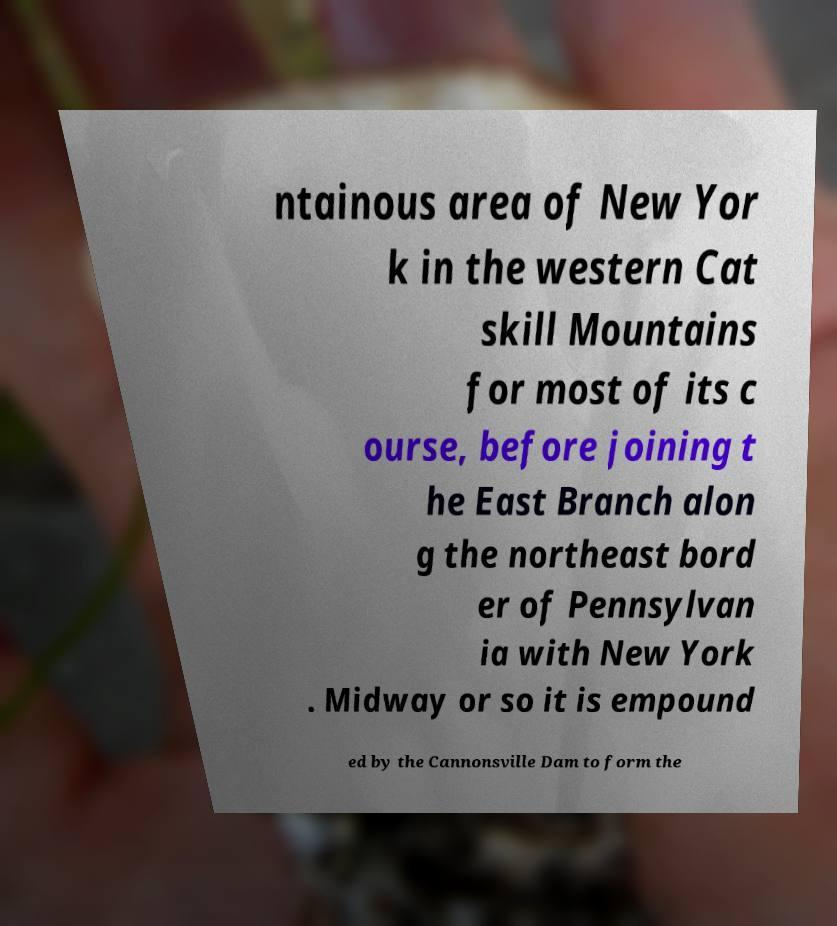Please read and relay the text visible in this image. What does it say? ntainous area of New Yor k in the western Cat skill Mountains for most of its c ourse, before joining t he East Branch alon g the northeast bord er of Pennsylvan ia with New York . Midway or so it is empound ed by the Cannonsville Dam to form the 